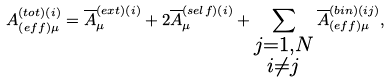Convert formula to latex. <formula><loc_0><loc_0><loc_500><loc_500>A _ { \left ( e f f \right ) \mu } ^ { ( t o t ) \left ( i \right ) } = \overline { A } _ { \mu } ^ { ( e x t ) \left ( i \right ) } + 2 \overline { A } _ { \mu } ^ { ( s e l f ) \left ( i \right ) } + \sum _ { \substack { j = 1 , N \\ i \neq j } } \overline { A } _ { \left ( e f f \right ) \mu } ^ { ( b i n ) \left ( i j \right ) } ,</formula> 